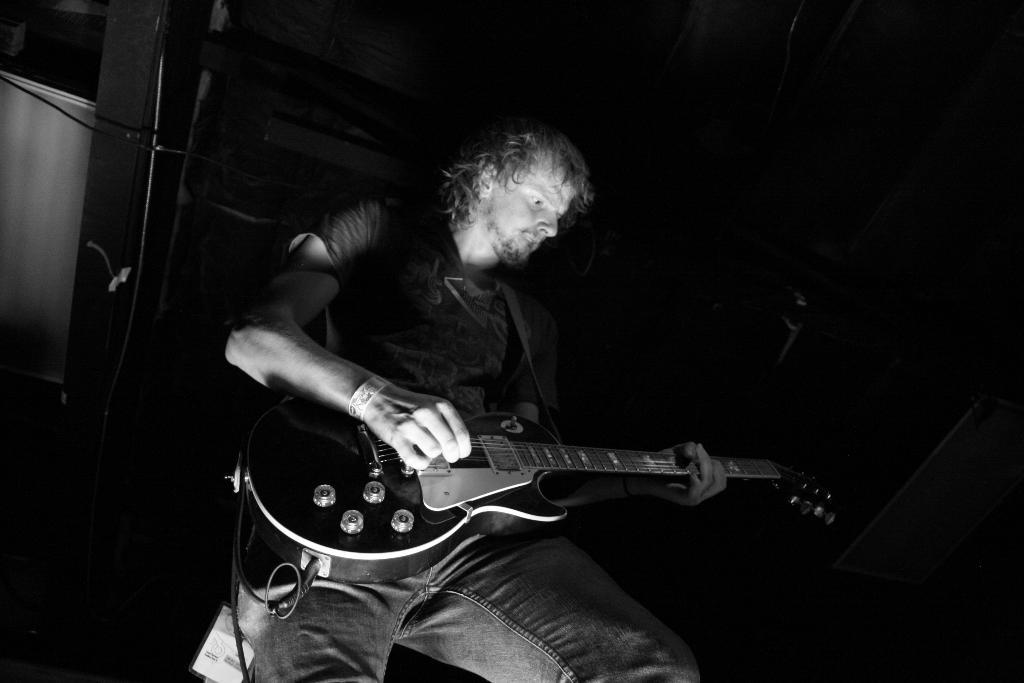What is the man in the image doing? The man is playing the guitar. What object is the man holding in the image? The man is holding a guitar. What can be seen in the background of the image? There is a dark background in the image, and some instruments are visible. What route does the man take to make his guitar discovery in the image? There is no mention of a guitar discovery in the image, and the man is already playing the guitar. What color is the discovery the man made in the image? There is no discovery mentioned in the image, and the man is playing the guitar. 